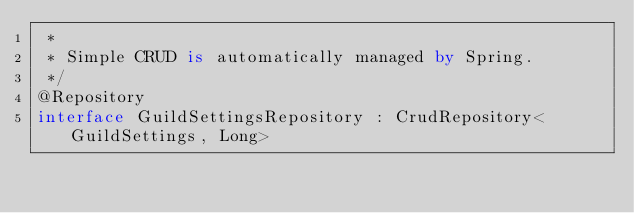<code> <loc_0><loc_0><loc_500><loc_500><_Kotlin_> *
 * Simple CRUD is automatically managed by Spring.
 */
@Repository
interface GuildSettingsRepository : CrudRepository<GuildSettings, Long></code> 